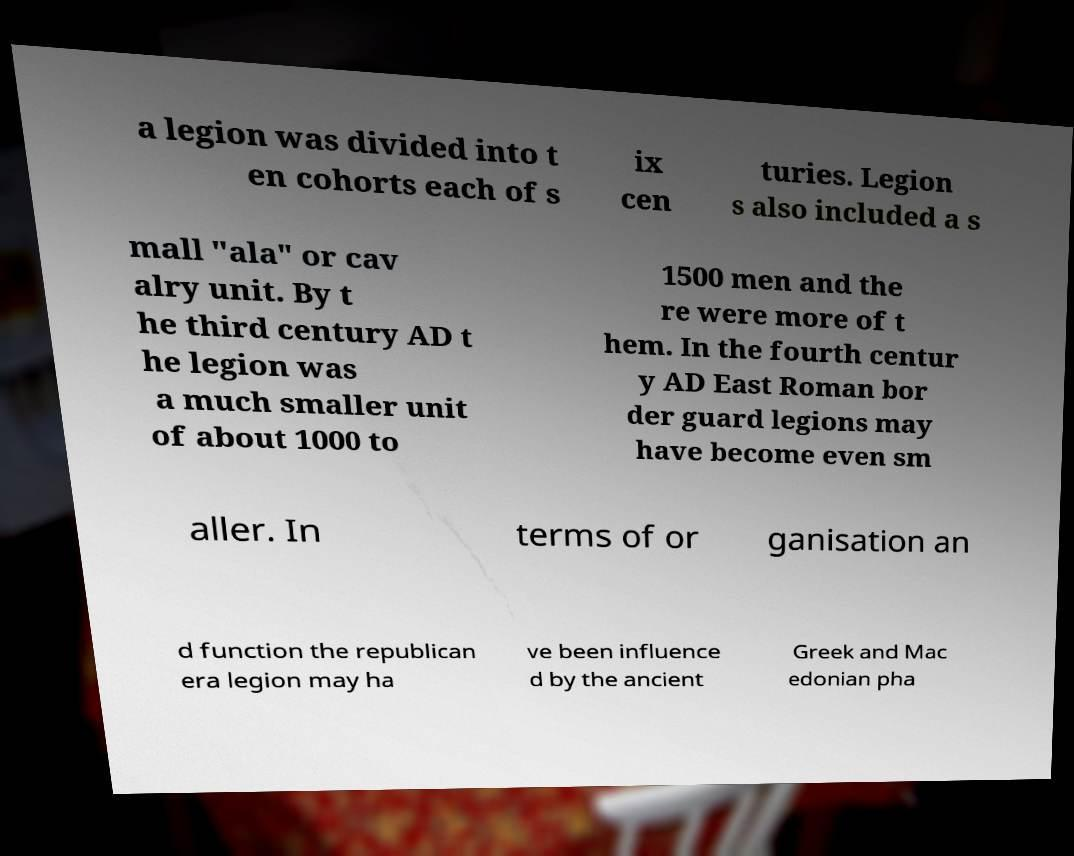For documentation purposes, I need the text within this image transcribed. Could you provide that? a legion was divided into t en cohorts each of s ix cen turies. Legion s also included a s mall "ala" or cav alry unit. By t he third century AD t he legion was a much smaller unit of about 1000 to 1500 men and the re were more of t hem. In the fourth centur y AD East Roman bor der guard legions may have become even sm aller. In terms of or ganisation an d function the republican era legion may ha ve been influence d by the ancient Greek and Mac edonian pha 